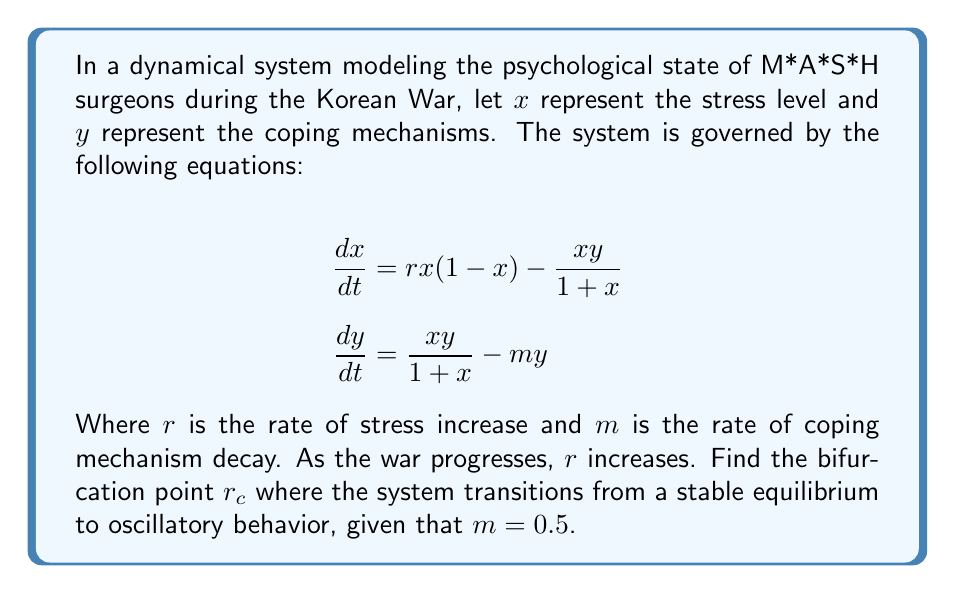Provide a solution to this math problem. To find the bifurcation point, we need to follow these steps:

1) First, find the equilibrium points by setting $\frac{dx}{dt} = \frac{dy}{dt} = 0$:

   $$rx(1-x) - \frac{xy}{1+x} = 0$$
   $$\frac{xy}{1+x} - my = 0$$

2) From the second equation, we can see that either $y = 0$ or $\frac{x}{1+x} = m$.

3) If $y = 0$, from the first equation we get $x = 0$ or $x = 1$. These are trivial equilibria.

4) For the non-trivial equilibrium, solve $\frac{x}{1+x} = m$:
   
   $$x = \frac{m}{1-m} = 1$$

5) Substitute this back into the first equation:

   $$r(1)(1-1) - \frac{1 \cdot y}{1+1} = 0$$
   $$-\frac{y}{2} = 0$$
   $$y = 0$$

6) This gives us the non-trivial equilibrium point $(1,0)$.

7) To find the bifurcation point, we need to calculate the Jacobian matrix at this point:

   $$J = \begin{bmatrix}
   r(1-2x) - \frac{y}{(1+x)^2} & -\frac{x}{1+x} \\
   \frac{y}{(1+x)^2} & \frac{x}{1+x} - m
   \end{bmatrix}$$

8) At $(1,0)$, this becomes:

   $$J = \begin{bmatrix}
   -r & -\frac{1}{2} \\
   0 & \frac{1}{2} - m
   \end{bmatrix}$$

9) The characteristic equation is:

   $$\lambda^2 + (r - \frac{1}{2} + m)\lambda + (mr - \frac{r}{2}) = 0$$

10) For a Hopf bifurcation to occur, we need the real part of the eigenvalues to be zero. This happens when:

    $$r - \frac{1}{2} + m = 0$$

11) Solving for $r$ with $m = 0.5$:

    $$r_c = 1 - m = 1 - 0.5 = 0.5$$

This is the bifurcation point where the system transitions from stable to oscillatory behavior.
Answer: $r_c = 0.5$ 